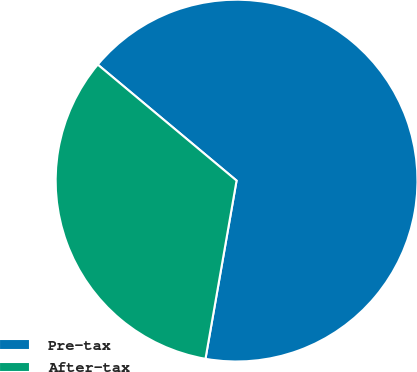Convert chart. <chart><loc_0><loc_0><loc_500><loc_500><pie_chart><fcel>Pre-tax<fcel>After-tax<nl><fcel>66.67%<fcel>33.33%<nl></chart> 